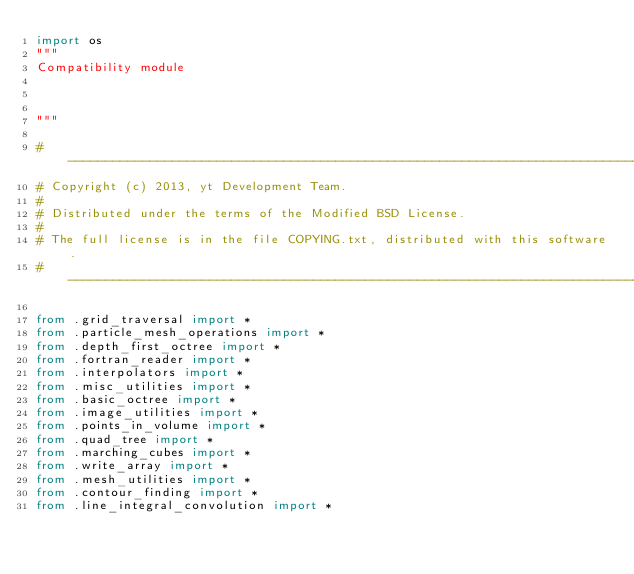<code> <loc_0><loc_0><loc_500><loc_500><_Python_>import os
"""
Compatibility module



"""

#-----------------------------------------------------------------------------
# Copyright (c) 2013, yt Development Team.
#
# Distributed under the terms of the Modified BSD License.
#
# The full license is in the file COPYING.txt, distributed with this software.
#-----------------------------------------------------------------------------

from .grid_traversal import *
from .particle_mesh_operations import *
from .depth_first_octree import *
from .fortran_reader import *
from .interpolators import *
from .misc_utilities import *
from .basic_octree import *
from .image_utilities import *
from .points_in_volume import *
from .quad_tree import *
from .marching_cubes import *
from .write_array import *
from .mesh_utilities import *
from .contour_finding import *
from .line_integral_convolution import *
</code> 